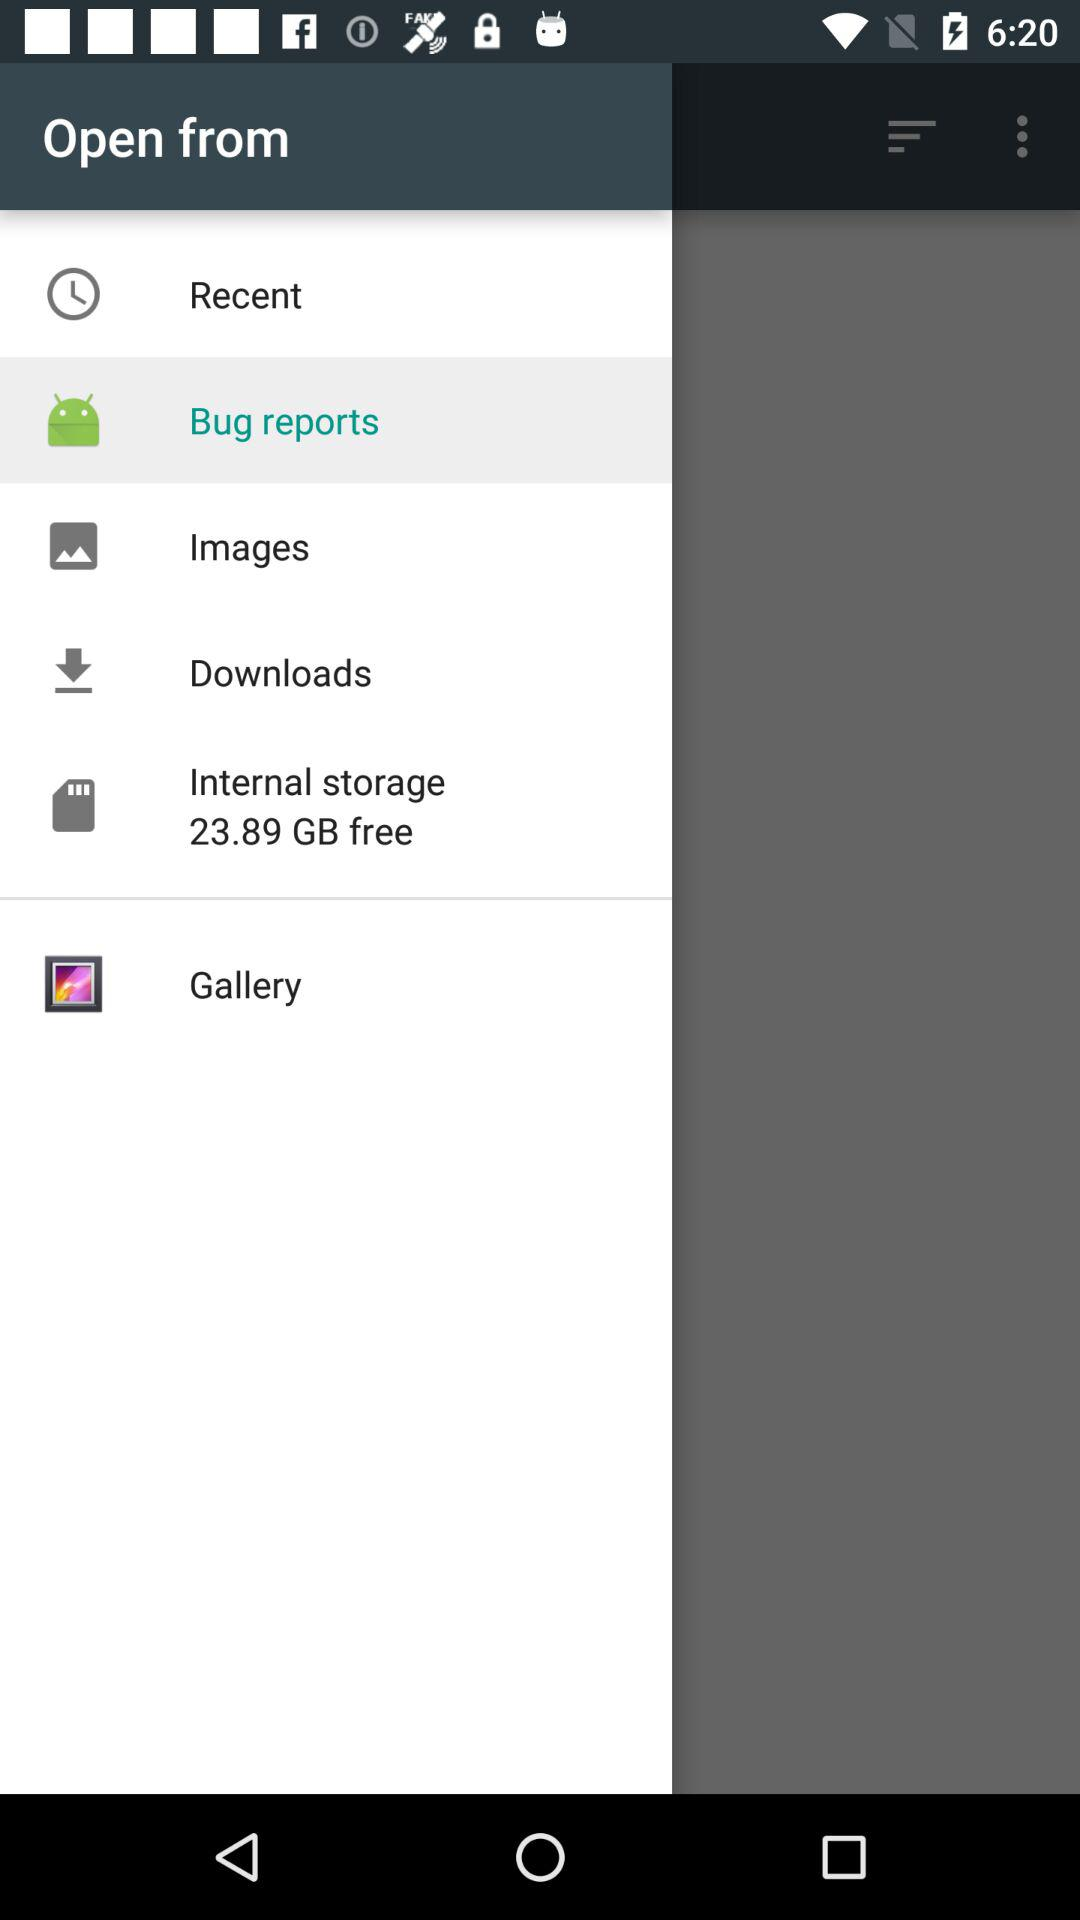How much free space is available on the internal storage?
Answer the question using a single word or phrase. 23.89 GB 